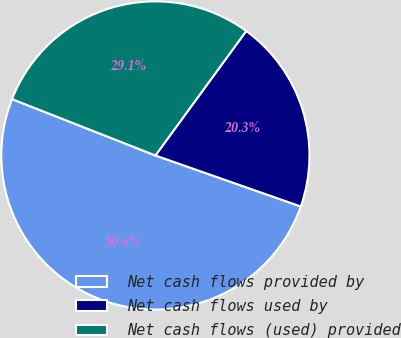Convert chart. <chart><loc_0><loc_0><loc_500><loc_500><pie_chart><fcel>Net cash flows provided by<fcel>Net cash flows used by<fcel>Net cash flows (used) provided<nl><fcel>50.59%<fcel>20.34%<fcel>29.07%<nl></chart> 